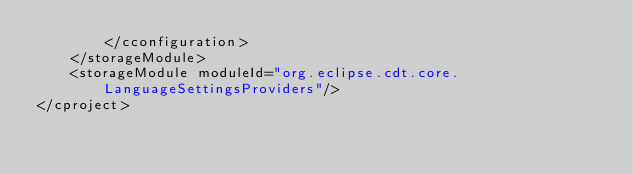<code> <loc_0><loc_0><loc_500><loc_500><_XML_>		</cconfiguration>
	</storageModule>
	<storageModule moduleId="org.eclipse.cdt.core.LanguageSettingsProviders"/>
</cproject>
</code> 